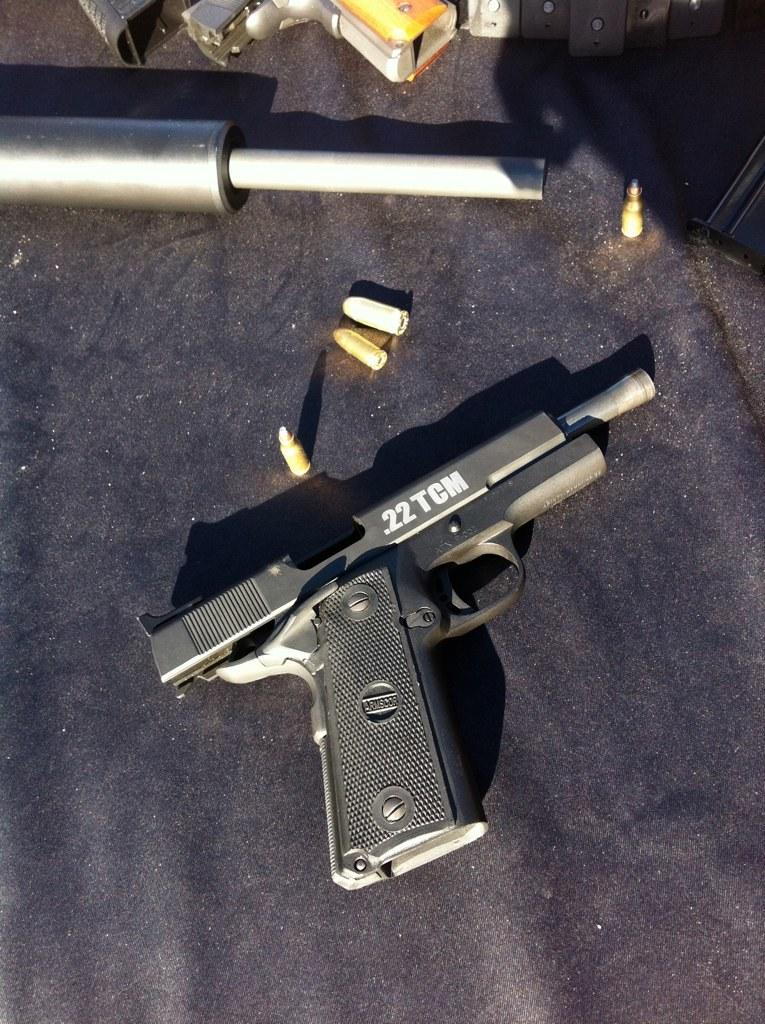What type of weapon is present in the image? There are guns in the image. What material are the objects made of in the image? There are metal objects in the image. What ammunition is visible in the image? There are bullets in the image. Where are the guns, metal objects, and bullets located in the image? The guns, metal objects, and bullets are on a platform. How does the pot contribute to the image? There is no pot present in the image. What role does the coal play in the image? There is no coal present in the image. 